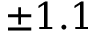Convert formula to latex. <formula><loc_0><loc_0><loc_500><loc_500>\pm 1 . 1</formula> 